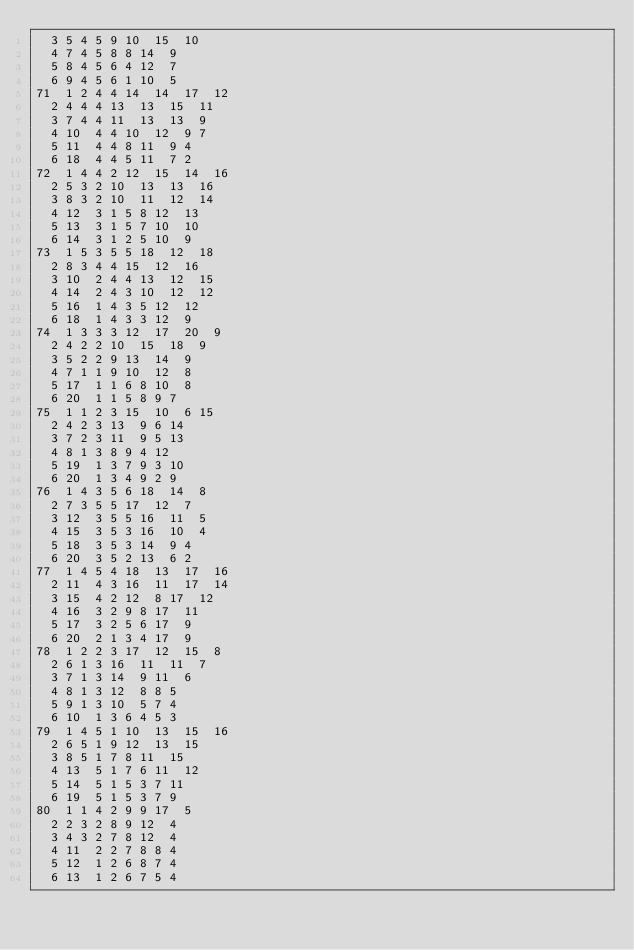<code> <loc_0><loc_0><loc_500><loc_500><_ObjectiveC_>	3	5	4	5	9	10	15	10	
	4	7	4	5	8	8	14	9	
	5	8	4	5	6	4	12	7	
	6	9	4	5	6	1	10	5	
71	1	2	4	4	14	14	17	12	
	2	4	4	4	13	13	15	11	
	3	7	4	4	11	13	13	9	
	4	10	4	4	10	12	9	7	
	5	11	4	4	8	11	9	4	
	6	18	4	4	5	11	7	2	
72	1	4	4	2	12	15	14	16	
	2	5	3	2	10	13	13	16	
	3	8	3	2	10	11	12	14	
	4	12	3	1	5	8	12	13	
	5	13	3	1	5	7	10	10	
	6	14	3	1	2	5	10	9	
73	1	5	3	5	5	18	12	18	
	2	8	3	4	4	15	12	16	
	3	10	2	4	4	13	12	15	
	4	14	2	4	3	10	12	12	
	5	16	1	4	3	5	12	12	
	6	18	1	4	3	3	12	9	
74	1	3	3	3	12	17	20	9	
	2	4	2	2	10	15	18	9	
	3	5	2	2	9	13	14	9	
	4	7	1	1	9	10	12	8	
	5	17	1	1	6	8	10	8	
	6	20	1	1	5	8	9	7	
75	1	1	2	3	15	10	6	15	
	2	4	2	3	13	9	6	14	
	3	7	2	3	11	9	5	13	
	4	8	1	3	8	9	4	12	
	5	19	1	3	7	9	3	10	
	6	20	1	3	4	9	2	9	
76	1	4	3	5	6	18	14	8	
	2	7	3	5	5	17	12	7	
	3	12	3	5	5	16	11	5	
	4	15	3	5	3	16	10	4	
	5	18	3	5	3	14	9	4	
	6	20	3	5	2	13	6	2	
77	1	4	5	4	18	13	17	16	
	2	11	4	3	16	11	17	14	
	3	15	4	2	12	8	17	12	
	4	16	3	2	9	8	17	11	
	5	17	3	2	5	6	17	9	
	6	20	2	1	3	4	17	9	
78	1	2	2	3	17	12	15	8	
	2	6	1	3	16	11	11	7	
	3	7	1	3	14	9	11	6	
	4	8	1	3	12	8	8	5	
	5	9	1	3	10	5	7	4	
	6	10	1	3	6	4	5	3	
79	1	4	5	1	10	13	15	16	
	2	6	5	1	9	12	13	15	
	3	8	5	1	7	8	11	15	
	4	13	5	1	7	6	11	12	
	5	14	5	1	5	3	7	11	
	6	19	5	1	5	3	7	9	
80	1	1	4	2	9	9	17	5	
	2	2	3	2	8	9	12	4	
	3	4	3	2	7	8	12	4	
	4	11	2	2	7	8	8	4	
	5	12	1	2	6	8	7	4	
	6	13	1	2	6	7	5	4	</code> 